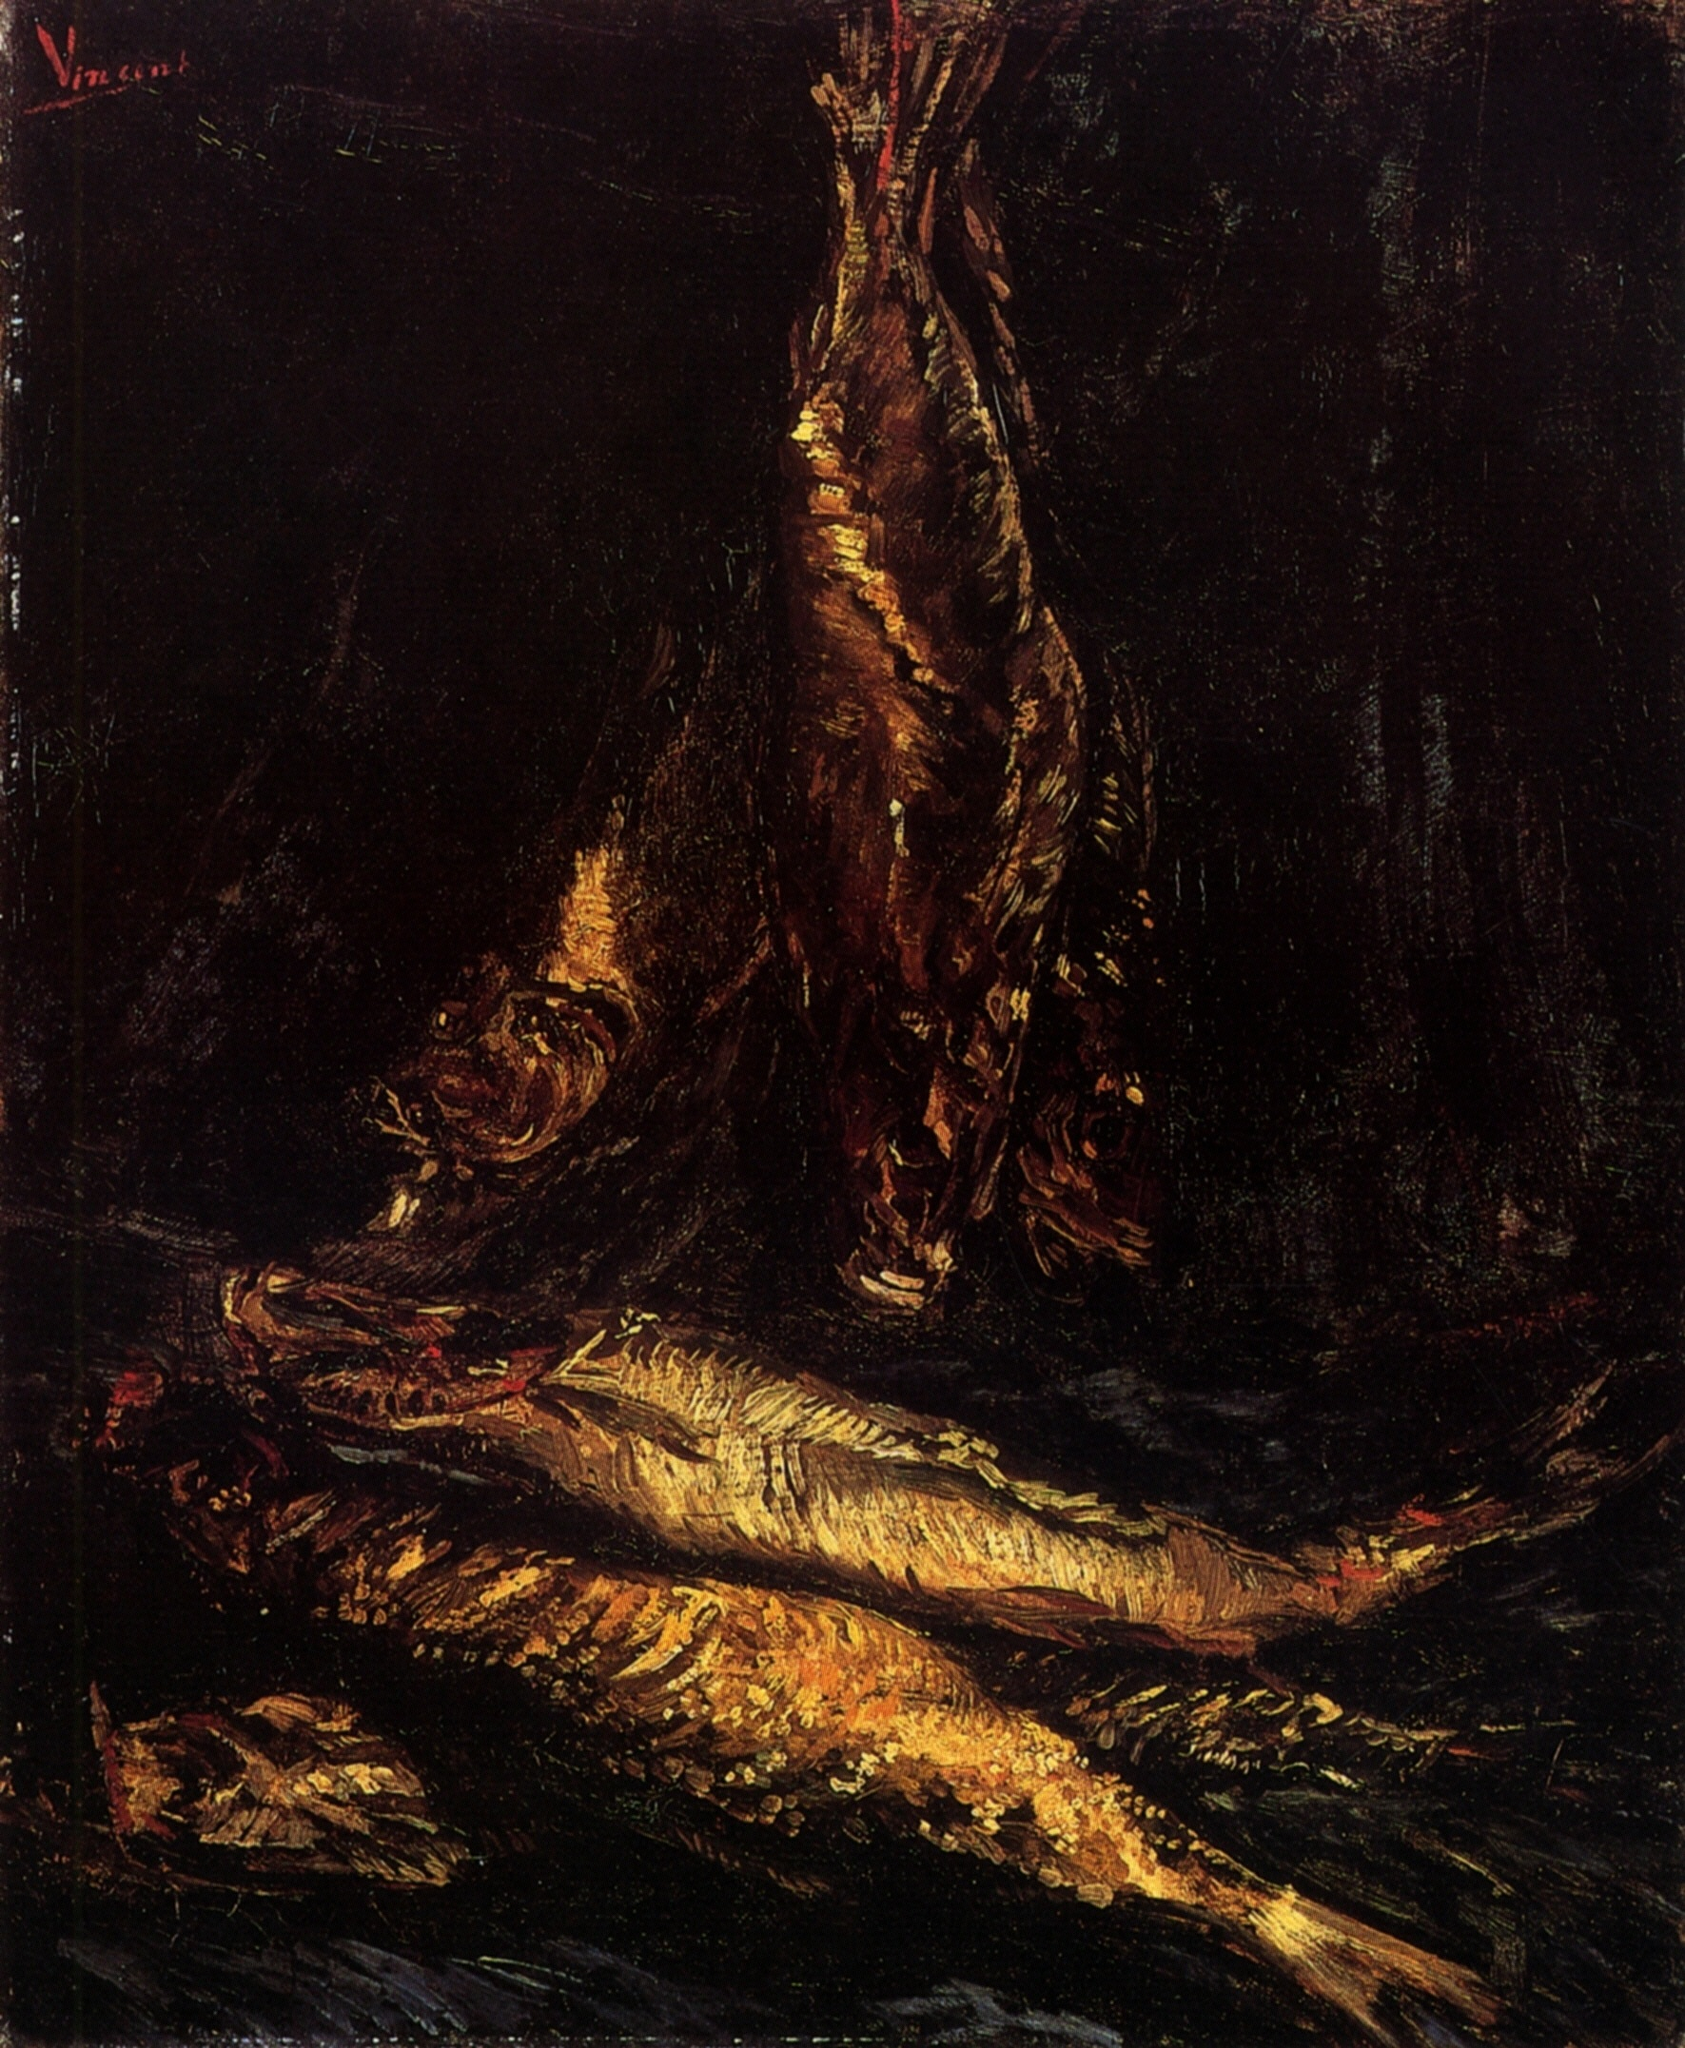Explain the visual content of the image in great detail. The image is a captivating representation of a still life of fish, painted in the distinctive style of impressionism. The artist has employed loose brushstrokes to create an image that is both realistic and abstract. The fish, the primary subjects of the painting, are arranged against a dark background, with the largest one hanging from a hook at the top. The attention to detail in the scales and fins of the fish is remarkable, adding a touch of realism to the otherwise abstract style. The color palette is predominantly dark, further emphasizing the fish. The painting likely originates from the 19th century, a period when the still life genre was quite popular. The overall composition and style suggest a confident and skilled hand behind the artwork. 